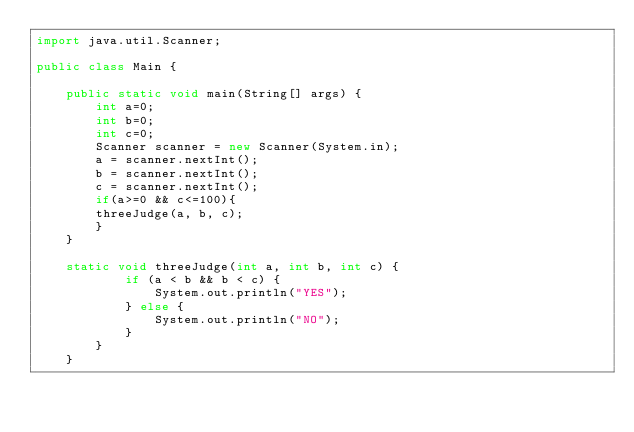<code> <loc_0><loc_0><loc_500><loc_500><_Java_>import java.util.Scanner;

public class Main {

	public static void main(String[] args) {
		int a=0;
		int b=0;
		int c=0;
		Scanner scanner = new Scanner(System.in);
		a = scanner.nextInt();
		b = scanner.nextInt();
		c = scanner.nextInt();
		if(a>=0 && c<=100){
		threeJudge(a, b, c);
		}
	}

	static void threeJudge(int a, int b, int c) {
			if (a < b && b < c) {
				System.out.println("YES");
			} else {
				System.out.println("NO");
			}
		}
	}</code> 